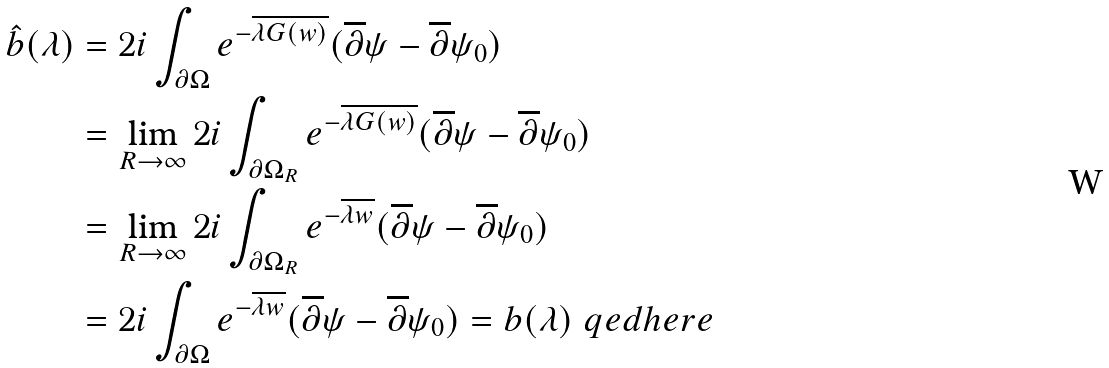<formula> <loc_0><loc_0><loc_500><loc_500>\hat { b } ( \lambda ) & = 2 i \int _ { \partial \Omega } e ^ { - \overline { \lambda G ( w ) } } ( \overline { \partial } \psi - \overline { \partial } \psi _ { 0 } ) \\ & = \lim _ { R \to \infty } 2 i \int _ { \partial \Omega _ { R } } e ^ { - \overline { \lambda G ( w ) } } ( \overline { \partial } \psi - \overline { \partial } \psi _ { 0 } ) \\ & = \lim _ { R \to \infty } 2 i \int _ { \partial \Omega _ { R } } e ^ { - \overline { \lambda w } } ( \overline { \partial } \psi - \overline { \partial } \psi _ { 0 } ) \\ & = 2 i \int _ { \partial \Omega } e ^ { - \overline { \lambda w } } ( \overline { \partial } \psi - \overline { \partial } \psi _ { 0 } ) = b ( \lambda ) \ q e d h e r e</formula> 